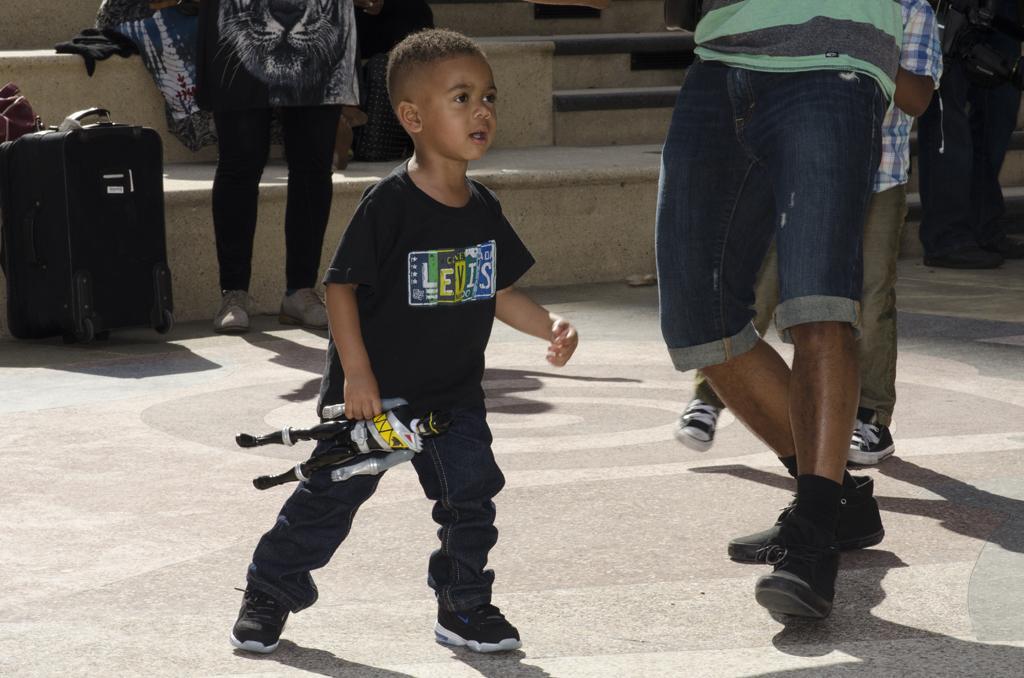In one or two sentences, can you explain what this image depicts? In the center we can see boy holding toy. Around him we can see some persons were standing,trolley,staircase and few more objects around him. 